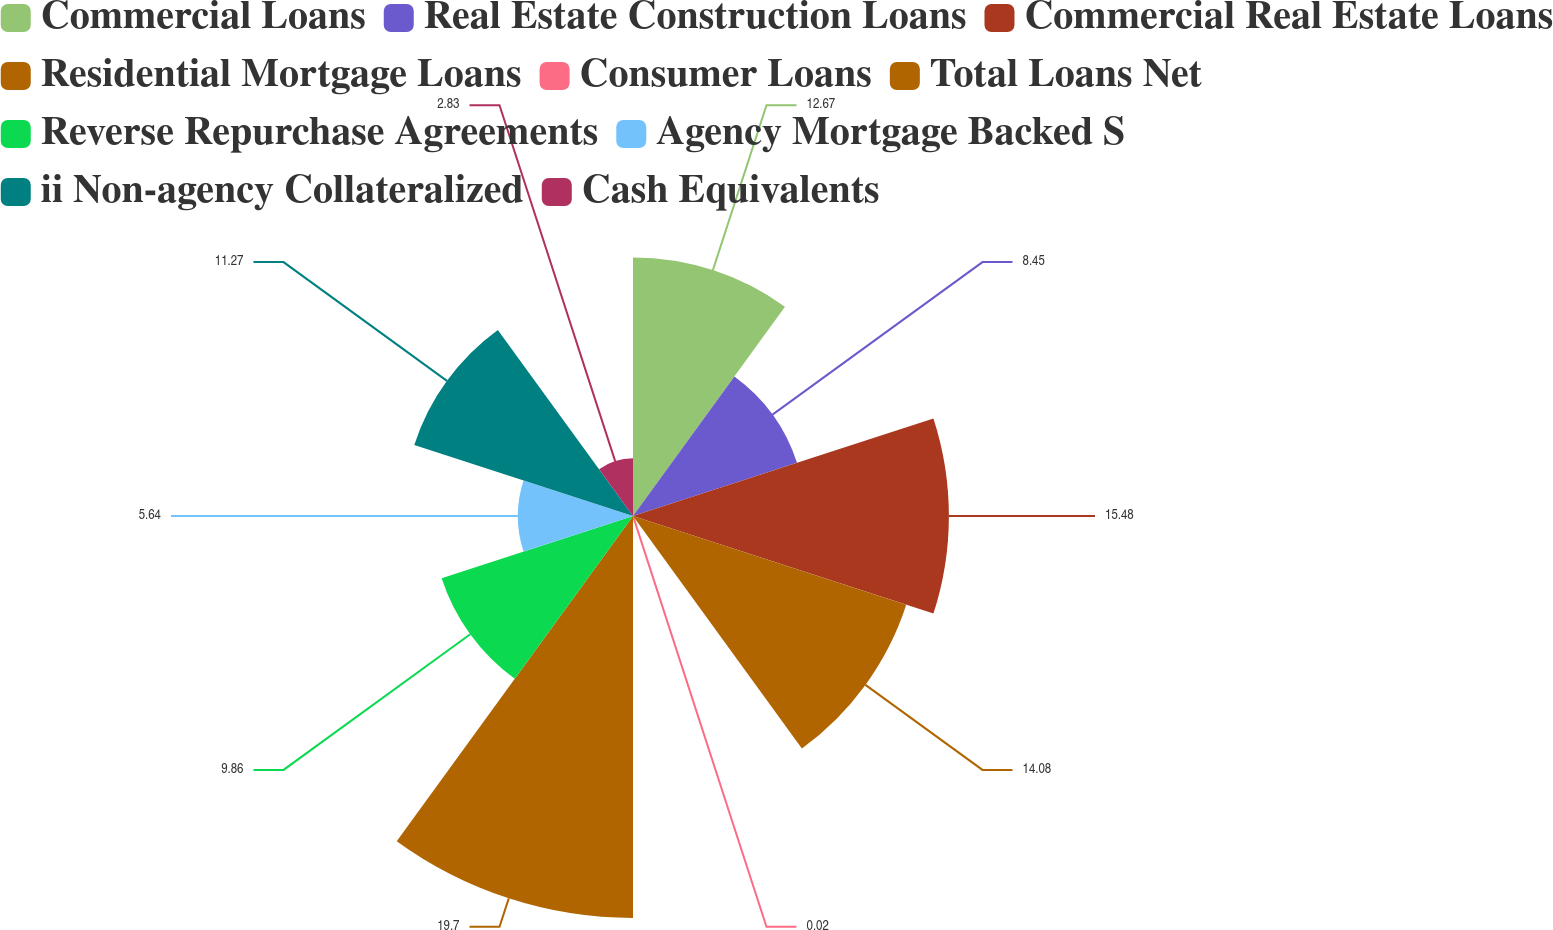Convert chart. <chart><loc_0><loc_0><loc_500><loc_500><pie_chart><fcel>Commercial Loans<fcel>Real Estate Construction Loans<fcel>Commercial Real Estate Loans<fcel>Residential Mortgage Loans<fcel>Consumer Loans<fcel>Total Loans Net<fcel>Reverse Repurchase Agreements<fcel>Agency Mortgage Backed S<fcel>ii Non-agency Collateralized<fcel>Cash Equivalents<nl><fcel>12.67%<fcel>8.45%<fcel>15.48%<fcel>14.08%<fcel>0.02%<fcel>19.7%<fcel>9.86%<fcel>5.64%<fcel>11.27%<fcel>2.83%<nl></chart> 